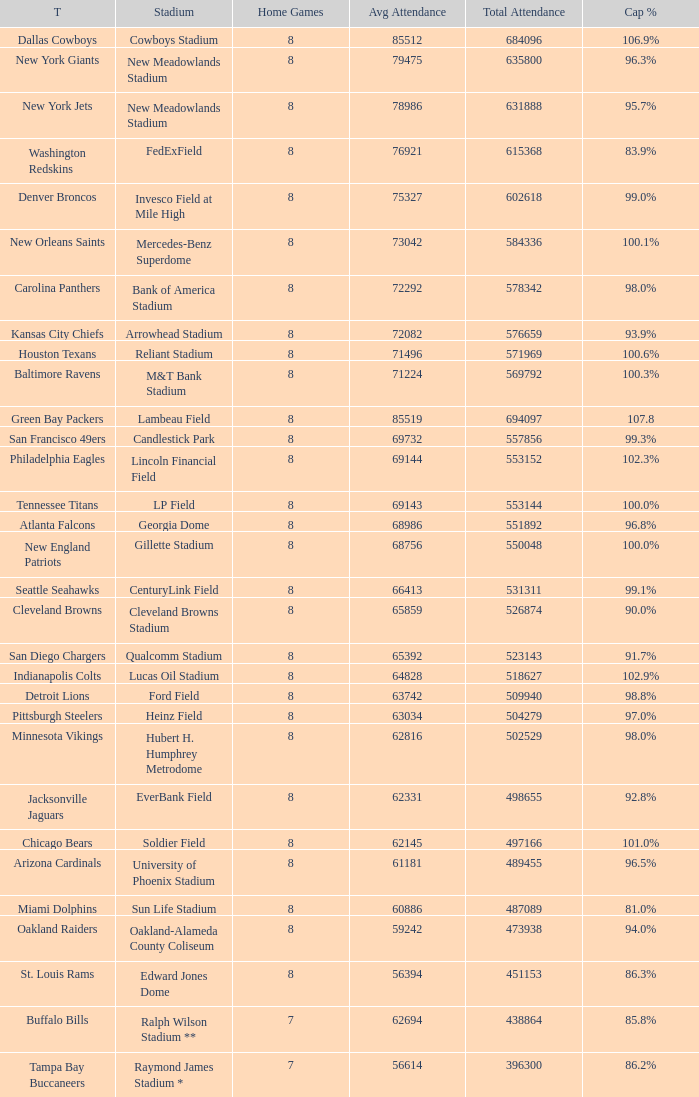What is the name of the team when the stadium is listed as Edward Jones Dome? St. Louis Rams. 